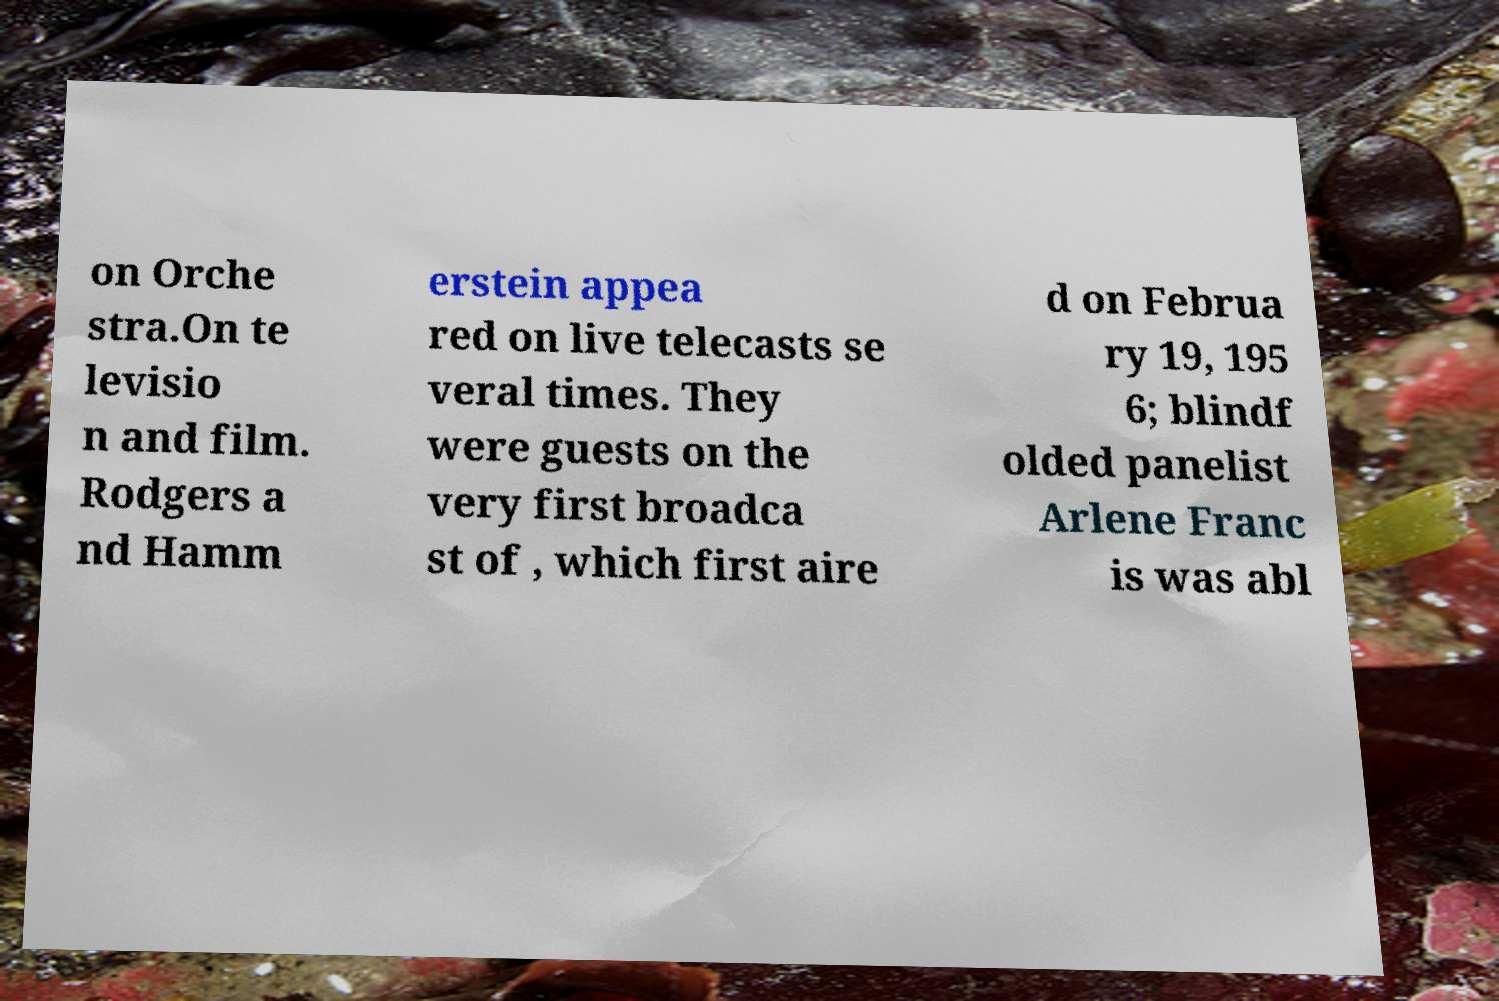There's text embedded in this image that I need extracted. Can you transcribe it verbatim? on Orche stra.On te levisio n and film. Rodgers a nd Hamm erstein appea red on live telecasts se veral times. They were guests on the very first broadca st of , which first aire d on Februa ry 19, 195 6; blindf olded panelist Arlene Franc is was abl 